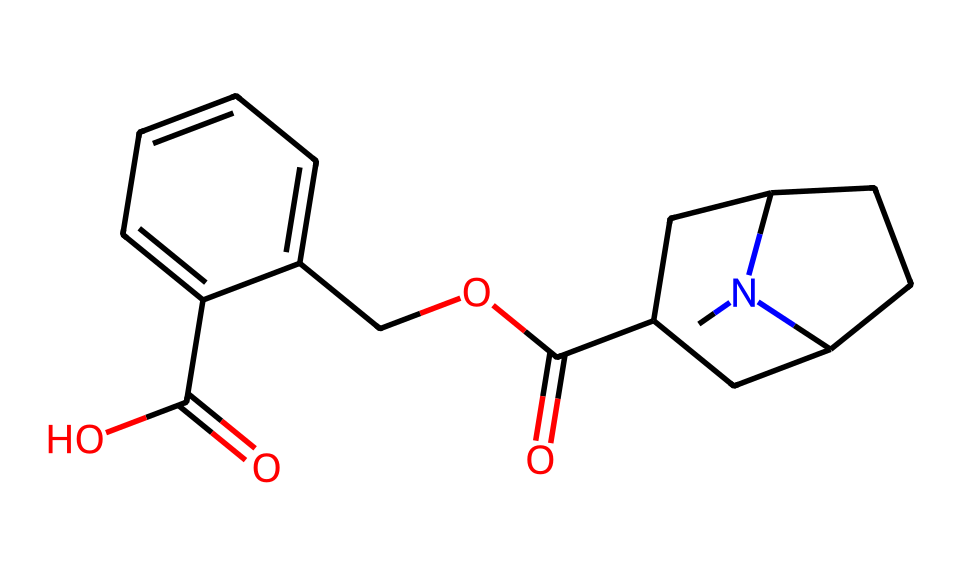What is the molecular formula of cocaine? To determine the molecular formula from the given SMILES, we need to count the number of each type of atom present. By interpreting the SMILES, we find there are 17 carbon atoms, 21 hydrogen atoms, 2 oxygen atoms, and 1 nitrogen atom, leading to the formula C17H21N2O2.
Answer: C17H21N2O2 How many rings are present in the structure of cocaine? Examining the SMILES structure reveals two distinct cycles: one in the nitrogen-containing part and another in the central part of the compound. Thus, there are two rings in cocaine.
Answer: 2 What type of chemical is cocaine classified as? Cocaine is primarily categorized as an alkaloid due to its natural origin and nitrogen content. It fits the definition of alkaloids, which are basic (alkaline) nitrogen-containing compounds extracted from plants.
Answer: alkaloid What functional groups can be identified in the cocaine structure? By analyzing the structure, we identify two functional groups: an ester group (R-CO-O-R') due to the carbonyl and oxide combination, and a carboxylic acid group (-COOH) on the aromatic ring. Both groups play significant roles in the chemical's activity.
Answer: ester and carboxylic acid What is the significance of the nitrogen atom in cocaine's structure? The nitrogen atom in cocaine is crucial as it contributes to the compound's basicity and potentially its pharmacological effects. Nitrogen in alkaloids often implies activity, including the ability to interact with biological systems, providing its psychoactive properties.
Answer: pharmacological effects 